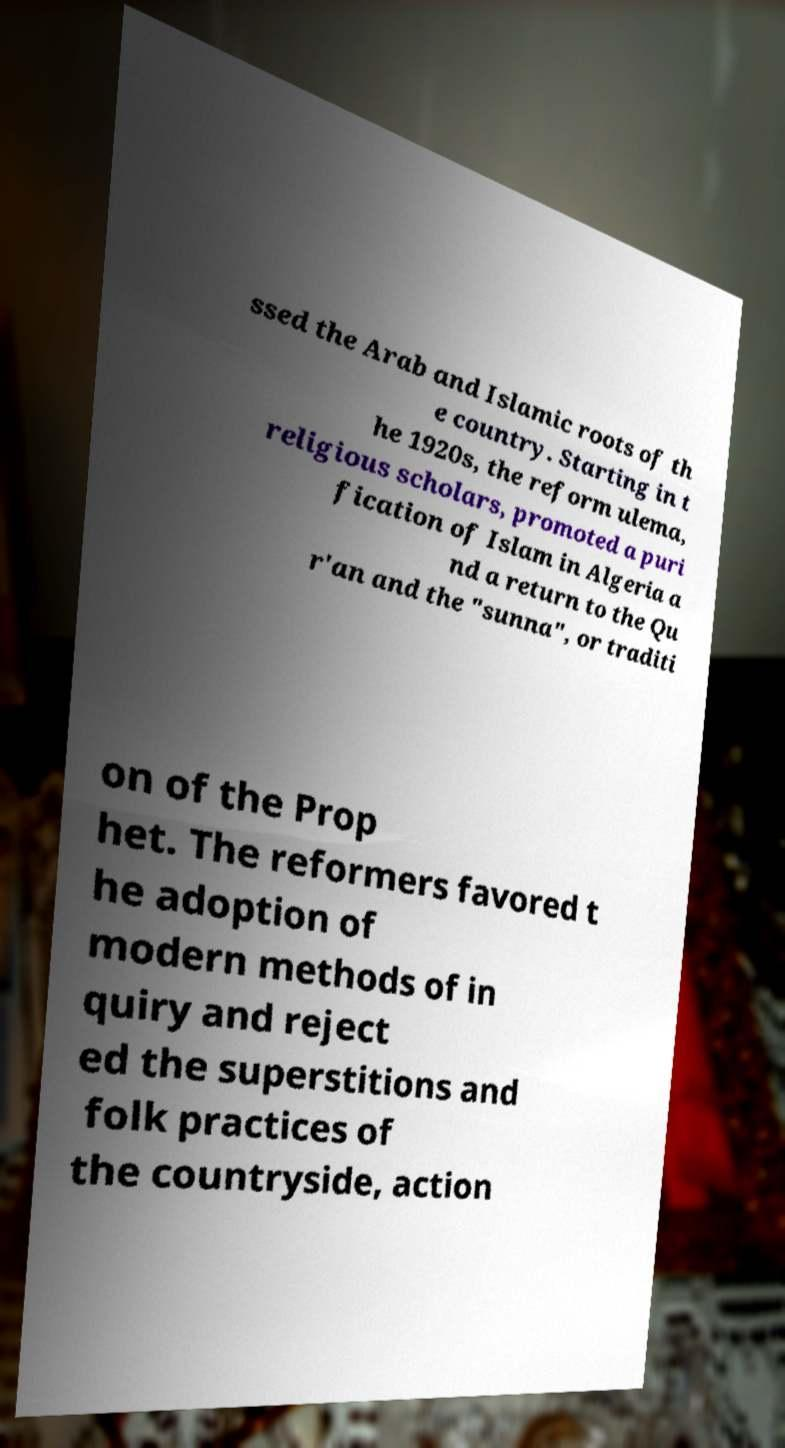Could you assist in decoding the text presented in this image and type it out clearly? ssed the Arab and Islamic roots of th e country. Starting in t he 1920s, the reform ulema, religious scholars, promoted a puri fication of Islam in Algeria a nd a return to the Qu r'an and the "sunna", or traditi on of the Prop het. The reformers favored t he adoption of modern methods of in quiry and reject ed the superstitions and folk practices of the countryside, action 